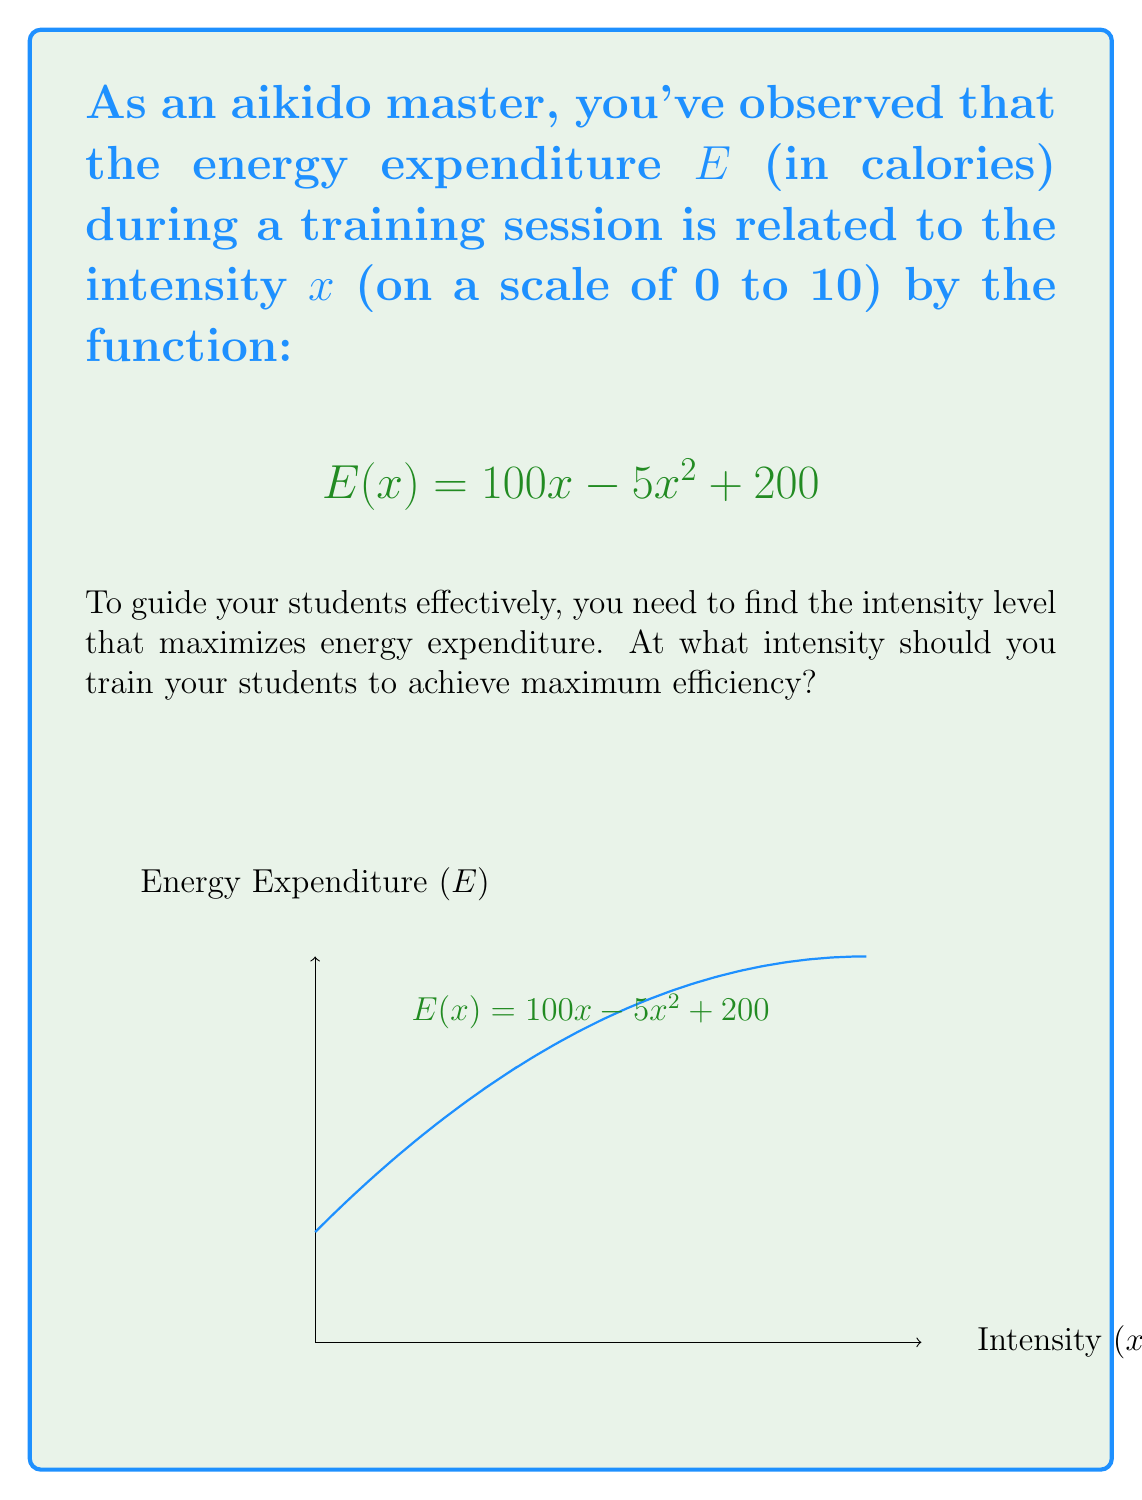What is the answer to this math problem? To find the maximum efficiency point, we need to follow these steps:

1) The maximum point occurs where the derivative of $E(x)$ is zero. Let's find $E'(x)$:

   $$E'(x) = 100 - 10x$$

2) Set $E'(x) = 0$ and solve for $x$:

   $$100 - 10x = 0$$
   $$-10x = -100$$
   $$x = 10$$

3) To confirm this is a maximum (not a minimum), check the second derivative:

   $$E''(x) = -10$$

   Since $E''(x)$ is negative, this confirms we have a maximum at $x = 10$.

4) However, our intensity scale only goes from 0 to 10. Since the function is quadratic and opens downward, the maximum within our domain will be at the upper limit.

5) Therefore, the maximum efficiency point occurs at an intensity of 10.

6) We can verify by calculating $E(10)$:

   $$E(10) = 100(10) - 5(10)^2 + 200 = 1000 - 500 + 200 = 700$$

This is indeed the highest point on our graph within the given domain.
Answer: $x = 10$ 